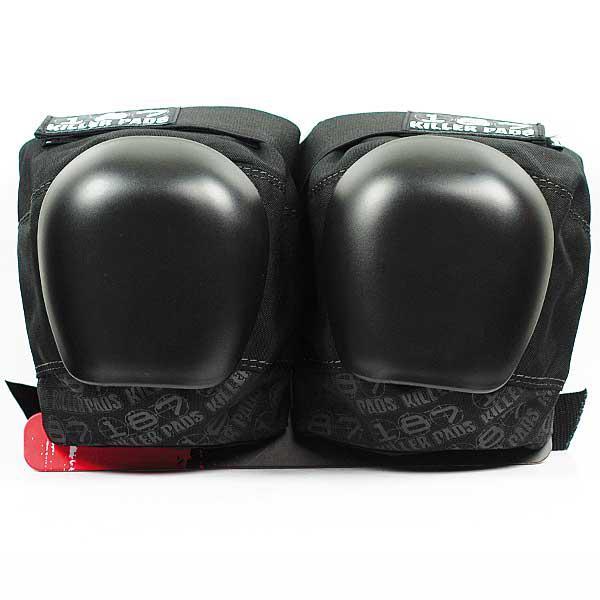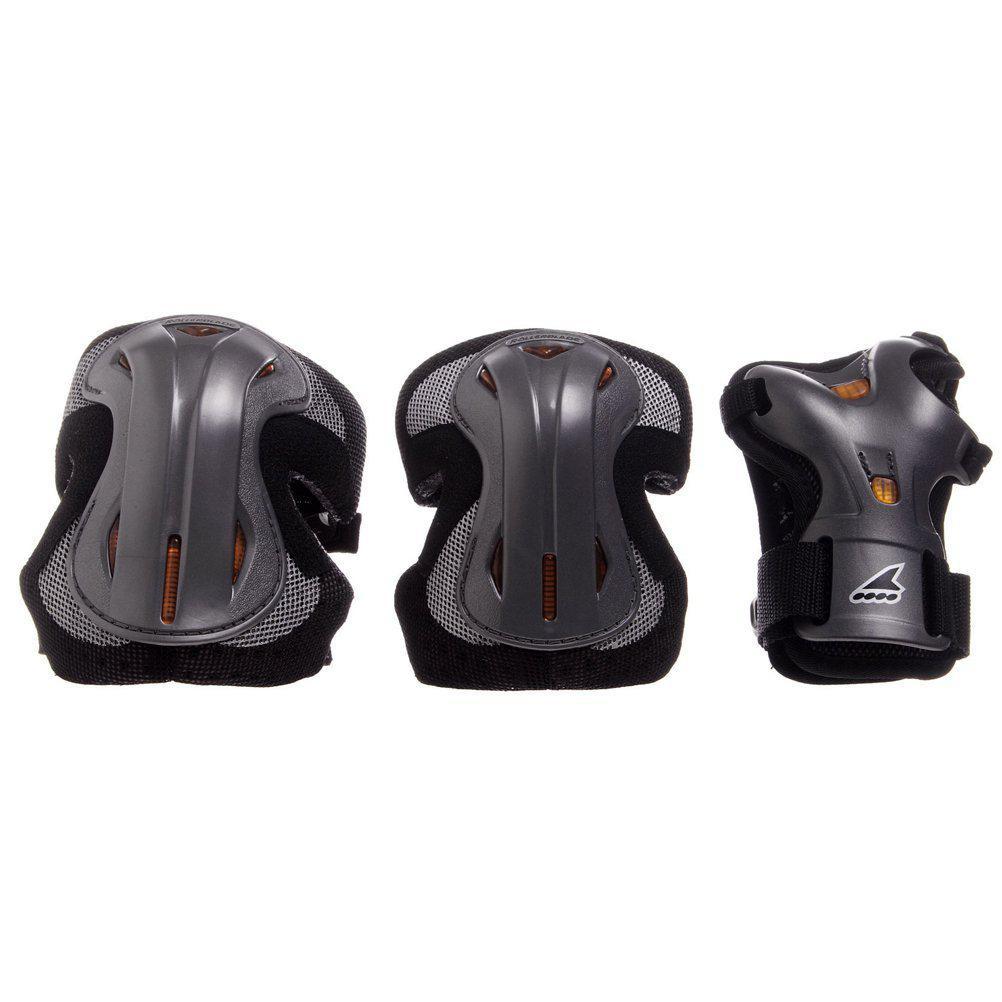The first image is the image on the left, the second image is the image on the right. Evaluate the accuracy of this statement regarding the images: "There are at least two sets of pads in the left image.". Is it true? Answer yes or no. No. 